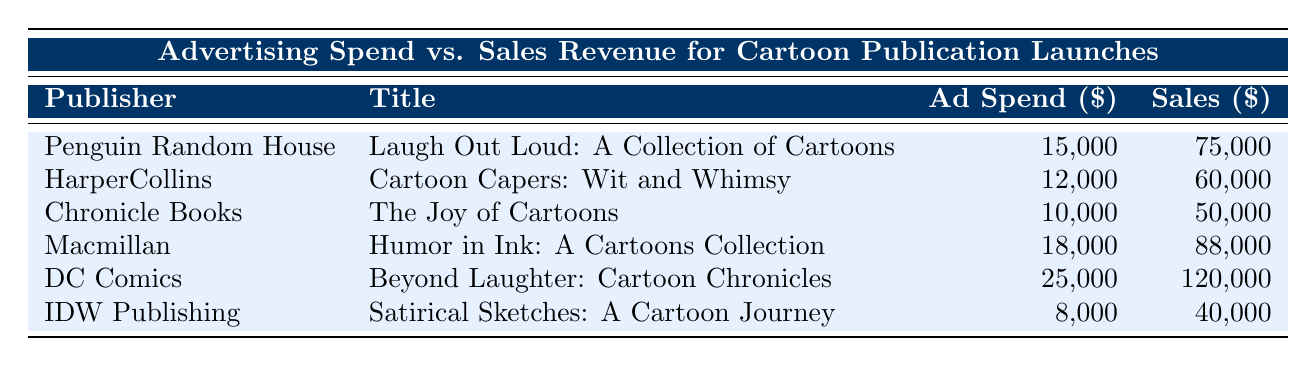What is the advertising spend for DC Comics? The table indicates that the advertising spend for DC Comics is listed under the Ad Spend column. Upon locating the entry for DC Comics, the value is 25,000.
Answer: 25,000 What is the total advertising spend from all the publishers? To find the total advertising spend, we need to sum up the values for each publisher: 15,000 + 12,000 + 10,000 + 18,000 + 25,000 + 8,000 = 88,000.
Answer: 88,000 Which title had the highest sales revenue? Scanning the Sales column reveals the highest revenue, which is 120,000. This value corresponds to the title "Beyond Laughter: Cartoon Chronicles" by DC Comics.
Answer: Beyond Laughter: Cartoon Chronicles Is the sales revenue for IDW Publishing higher than the advertising spend? Looking at the values for IDW Publishing, the sales revenue is 40,000 and the advertising spend is 8,000. Since 40,000 is greater than 8,000, the statement is true.
Answer: Yes What is the average sales revenue for the titles listed in the table? To find the average sales revenue, first we sum up the sales revenues: 75,000 + 60,000 + 50,000 + 88,000 + 120,000 + 40,000 = 433,000. There are six titles, so the average is 433,000 / 6 = 72,166.67.
Answer: 72,166.67 If Macmillan had increased its advertising spend by 5,000, what would the new ratio of advertising spend to sales revenue be? The original advertising spend for Macmillan is 18,000. With the increase, it becomes 23,000. The sales revenue remains 88,000. The new ratio is 23,000 / 88,000, which equals approximately 0.2614.
Answer: 0.2614 Which publisher had the lowest advertising spend? Inspecting the Ad Spend column, the lowest value is 8,000, which corresponds to IDW Publishing.
Answer: IDW Publishing How much more was the advertising spend for Macmillan compared to Chronicle Books? For Macmillan, the advertising spend is 18,000 and for Chronicle Books it is 10,000. The difference is 18,000 - 10,000 = 8,000.
Answer: 8,000 Is the sales revenue from "Humor in Ink: A Cartoons Collection" greater than the combined sales revenue of "Cartoon Capers: Wit and Whimsy" and "The Joy of Cartoons"? The sales revenue for "Humor in Ink" is 88,000. The combined sales revenue for the other two titles is 60,000 + 50,000 = 110,000. Since 88,000 is less than 110,000, the statement is false.
Answer: No 